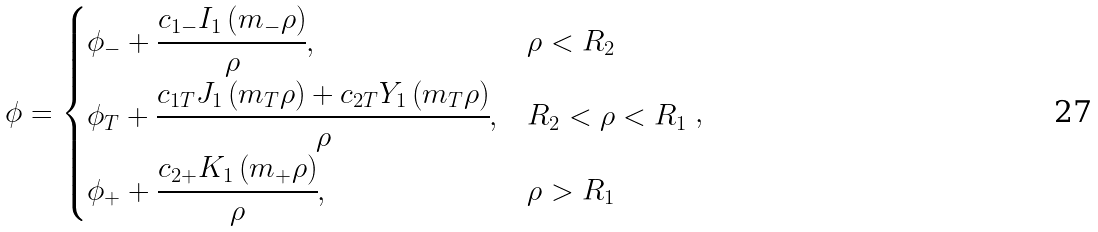<formula> <loc_0><loc_0><loc_500><loc_500>\phi = \begin{cases} \phi _ { - } + \cfrac { { c _ { 1 - } I _ { 1 } \left ( { m _ { - } \rho } \right ) } } { \rho } , & \rho < R _ { 2 } \\ \phi _ { T } + \cfrac { { c _ { 1 T } J _ { 1 } \left ( { m _ { T } \rho } \right ) + c _ { 2 T } Y _ { 1 } \left ( { m _ { T } \rho } \right ) } } { \rho } , & R _ { 2 } < \rho < R _ { 1 } \\ \phi _ { + } + \cfrac { { c _ { 2 + } K _ { 1 } \left ( { m _ { + } \rho } \right ) } } { \rho } , & \rho > R _ { 1 } \\ \end{cases} ,</formula> 